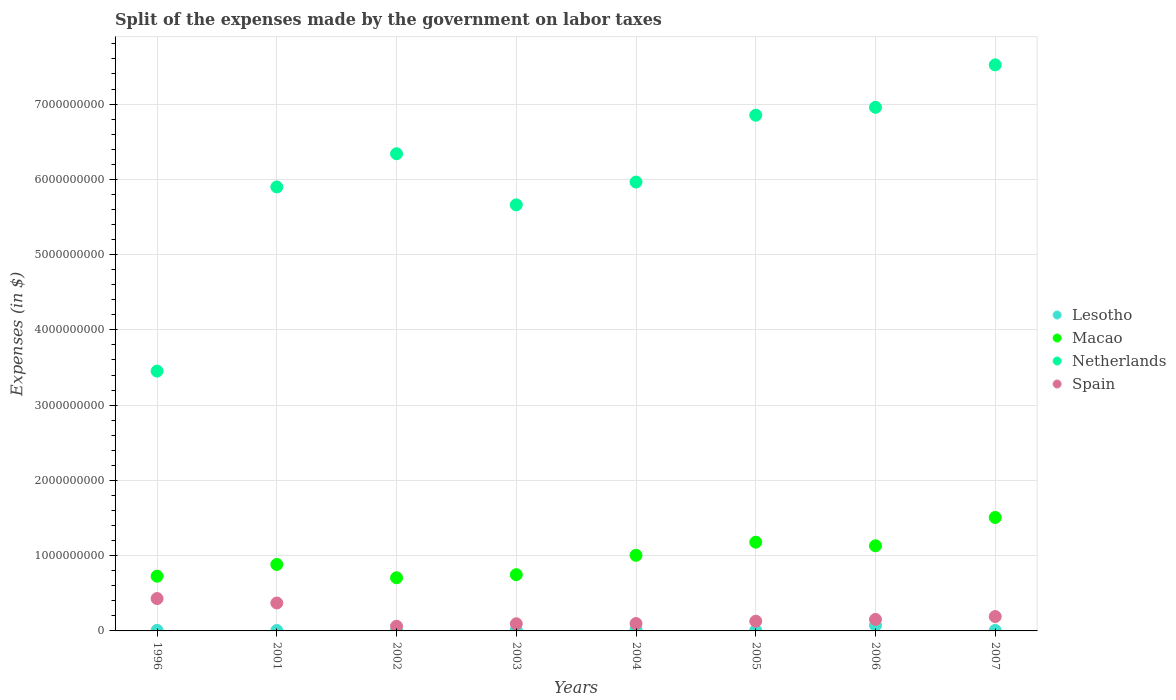Is the number of dotlines equal to the number of legend labels?
Offer a terse response. Yes. What is the expenses made by the government on labor taxes in Lesotho in 2003?
Give a very brief answer. 1.05e+07. Across all years, what is the maximum expenses made by the government on labor taxes in Lesotho?
Your answer should be compact. 7.48e+07. Across all years, what is the minimum expenses made by the government on labor taxes in Netherlands?
Your answer should be compact. 3.45e+09. In which year was the expenses made by the government on labor taxes in Macao maximum?
Give a very brief answer. 2007. In which year was the expenses made by the government on labor taxes in Spain minimum?
Offer a very short reply. 2002. What is the total expenses made by the government on labor taxes in Macao in the graph?
Offer a very short reply. 7.89e+09. What is the difference between the expenses made by the government on labor taxes in Netherlands in 2001 and that in 2003?
Provide a short and direct response. 2.38e+08. What is the difference between the expenses made by the government on labor taxes in Macao in 2002 and the expenses made by the government on labor taxes in Spain in 2005?
Provide a succinct answer. 5.77e+08. What is the average expenses made by the government on labor taxes in Macao per year?
Your answer should be compact. 9.86e+08. In the year 2005, what is the difference between the expenses made by the government on labor taxes in Macao and expenses made by the government on labor taxes in Lesotho?
Your answer should be very brief. 1.17e+09. What is the ratio of the expenses made by the government on labor taxes in Macao in 2004 to that in 2006?
Your answer should be very brief. 0.89. Is the expenses made by the government on labor taxes in Lesotho in 2001 less than that in 2007?
Provide a succinct answer. Yes. Is the difference between the expenses made by the government on labor taxes in Macao in 2001 and 2002 greater than the difference between the expenses made by the government on labor taxes in Lesotho in 2001 and 2002?
Your response must be concise. Yes. What is the difference between the highest and the second highest expenses made by the government on labor taxes in Macao?
Provide a short and direct response. 3.28e+08. What is the difference between the highest and the lowest expenses made by the government on labor taxes in Lesotho?
Offer a very short reply. 6.95e+07. In how many years, is the expenses made by the government on labor taxes in Netherlands greater than the average expenses made by the government on labor taxes in Netherlands taken over all years?
Provide a short and direct response. 4. Is it the case that in every year, the sum of the expenses made by the government on labor taxes in Macao and expenses made by the government on labor taxes in Netherlands  is greater than the sum of expenses made by the government on labor taxes in Lesotho and expenses made by the government on labor taxes in Spain?
Your answer should be very brief. Yes. Is the expenses made by the government on labor taxes in Macao strictly greater than the expenses made by the government on labor taxes in Spain over the years?
Your answer should be very brief. Yes. Is the expenses made by the government on labor taxes in Macao strictly less than the expenses made by the government on labor taxes in Spain over the years?
Make the answer very short. No. How many dotlines are there?
Ensure brevity in your answer.  4. Are the values on the major ticks of Y-axis written in scientific E-notation?
Provide a short and direct response. No. Does the graph contain any zero values?
Provide a succinct answer. No. How many legend labels are there?
Provide a short and direct response. 4. How are the legend labels stacked?
Your response must be concise. Vertical. What is the title of the graph?
Offer a very short reply. Split of the expenses made by the government on labor taxes. Does "Finland" appear as one of the legend labels in the graph?
Ensure brevity in your answer.  No. What is the label or title of the X-axis?
Offer a terse response. Years. What is the label or title of the Y-axis?
Provide a short and direct response. Expenses (in $). What is the Expenses (in $) in Lesotho in 1996?
Provide a succinct answer. 7.20e+06. What is the Expenses (in $) in Macao in 1996?
Provide a succinct answer. 7.27e+08. What is the Expenses (in $) in Netherlands in 1996?
Keep it short and to the point. 3.45e+09. What is the Expenses (in $) in Spain in 1996?
Give a very brief answer. 4.30e+08. What is the Expenses (in $) in Lesotho in 2001?
Offer a very short reply. 5.30e+06. What is the Expenses (in $) in Macao in 2001?
Your answer should be compact. 8.83e+08. What is the Expenses (in $) in Netherlands in 2001?
Offer a terse response. 5.90e+09. What is the Expenses (in $) of Spain in 2001?
Make the answer very short. 3.71e+08. What is the Expenses (in $) in Lesotho in 2002?
Provide a short and direct response. 6.40e+06. What is the Expenses (in $) in Macao in 2002?
Provide a short and direct response. 7.06e+08. What is the Expenses (in $) of Netherlands in 2002?
Provide a short and direct response. 6.34e+09. What is the Expenses (in $) in Spain in 2002?
Keep it short and to the point. 6.20e+07. What is the Expenses (in $) in Lesotho in 2003?
Provide a short and direct response. 1.05e+07. What is the Expenses (in $) of Macao in 2003?
Offer a very short reply. 7.47e+08. What is the Expenses (in $) in Netherlands in 2003?
Your response must be concise. 5.66e+09. What is the Expenses (in $) of Spain in 2003?
Give a very brief answer. 9.50e+07. What is the Expenses (in $) in Lesotho in 2004?
Make the answer very short. 1.78e+07. What is the Expenses (in $) of Macao in 2004?
Provide a succinct answer. 1.00e+09. What is the Expenses (in $) of Netherlands in 2004?
Offer a very short reply. 5.96e+09. What is the Expenses (in $) in Spain in 2004?
Keep it short and to the point. 9.80e+07. What is the Expenses (in $) in Lesotho in 2005?
Your answer should be very brief. 6.74e+06. What is the Expenses (in $) of Macao in 2005?
Your answer should be very brief. 1.18e+09. What is the Expenses (in $) of Netherlands in 2005?
Give a very brief answer. 6.85e+09. What is the Expenses (in $) in Spain in 2005?
Provide a succinct answer. 1.29e+08. What is the Expenses (in $) of Lesotho in 2006?
Your answer should be compact. 7.48e+07. What is the Expenses (in $) of Macao in 2006?
Provide a short and direct response. 1.13e+09. What is the Expenses (in $) in Netherlands in 2006?
Provide a succinct answer. 6.96e+09. What is the Expenses (in $) in Spain in 2006?
Keep it short and to the point. 1.53e+08. What is the Expenses (in $) of Lesotho in 2007?
Make the answer very short. 6.62e+06. What is the Expenses (in $) of Macao in 2007?
Make the answer very short. 1.51e+09. What is the Expenses (in $) of Netherlands in 2007?
Keep it short and to the point. 7.52e+09. What is the Expenses (in $) in Spain in 2007?
Keep it short and to the point. 1.91e+08. Across all years, what is the maximum Expenses (in $) in Lesotho?
Offer a terse response. 7.48e+07. Across all years, what is the maximum Expenses (in $) in Macao?
Provide a short and direct response. 1.51e+09. Across all years, what is the maximum Expenses (in $) of Netherlands?
Give a very brief answer. 7.52e+09. Across all years, what is the maximum Expenses (in $) of Spain?
Ensure brevity in your answer.  4.30e+08. Across all years, what is the minimum Expenses (in $) of Lesotho?
Offer a very short reply. 5.30e+06. Across all years, what is the minimum Expenses (in $) of Macao?
Offer a very short reply. 7.06e+08. Across all years, what is the minimum Expenses (in $) in Netherlands?
Offer a terse response. 3.45e+09. Across all years, what is the minimum Expenses (in $) in Spain?
Give a very brief answer. 6.20e+07. What is the total Expenses (in $) in Lesotho in the graph?
Give a very brief answer. 1.35e+08. What is the total Expenses (in $) of Macao in the graph?
Make the answer very short. 7.89e+09. What is the total Expenses (in $) of Netherlands in the graph?
Make the answer very short. 4.86e+1. What is the total Expenses (in $) in Spain in the graph?
Ensure brevity in your answer.  1.53e+09. What is the difference between the Expenses (in $) in Lesotho in 1996 and that in 2001?
Make the answer very short. 1.90e+06. What is the difference between the Expenses (in $) in Macao in 1996 and that in 2001?
Ensure brevity in your answer.  -1.56e+08. What is the difference between the Expenses (in $) in Netherlands in 1996 and that in 2001?
Provide a short and direct response. -2.45e+09. What is the difference between the Expenses (in $) in Spain in 1996 and that in 2001?
Your answer should be very brief. 5.90e+07. What is the difference between the Expenses (in $) of Macao in 1996 and that in 2002?
Provide a short and direct response. 2.08e+07. What is the difference between the Expenses (in $) of Netherlands in 1996 and that in 2002?
Your answer should be very brief. -2.89e+09. What is the difference between the Expenses (in $) of Spain in 1996 and that in 2002?
Your answer should be compact. 3.68e+08. What is the difference between the Expenses (in $) of Lesotho in 1996 and that in 2003?
Give a very brief answer. -3.28e+06. What is the difference between the Expenses (in $) in Macao in 1996 and that in 2003?
Make the answer very short. -1.99e+07. What is the difference between the Expenses (in $) of Netherlands in 1996 and that in 2003?
Provide a short and direct response. -2.21e+09. What is the difference between the Expenses (in $) of Spain in 1996 and that in 2003?
Give a very brief answer. 3.35e+08. What is the difference between the Expenses (in $) in Lesotho in 1996 and that in 2004?
Provide a short and direct response. -1.06e+07. What is the difference between the Expenses (in $) in Macao in 1996 and that in 2004?
Your answer should be very brief. -2.77e+08. What is the difference between the Expenses (in $) in Netherlands in 1996 and that in 2004?
Offer a very short reply. -2.51e+09. What is the difference between the Expenses (in $) of Spain in 1996 and that in 2004?
Your answer should be very brief. 3.32e+08. What is the difference between the Expenses (in $) in Lesotho in 1996 and that in 2005?
Provide a succinct answer. 4.65e+05. What is the difference between the Expenses (in $) of Macao in 1996 and that in 2005?
Provide a short and direct response. -4.52e+08. What is the difference between the Expenses (in $) in Netherlands in 1996 and that in 2005?
Make the answer very short. -3.40e+09. What is the difference between the Expenses (in $) in Spain in 1996 and that in 2005?
Your answer should be compact. 3.01e+08. What is the difference between the Expenses (in $) of Lesotho in 1996 and that in 2006?
Your answer should be very brief. -6.76e+07. What is the difference between the Expenses (in $) of Macao in 1996 and that in 2006?
Keep it short and to the point. -4.04e+08. What is the difference between the Expenses (in $) of Netherlands in 1996 and that in 2006?
Make the answer very short. -3.50e+09. What is the difference between the Expenses (in $) in Spain in 1996 and that in 2006?
Give a very brief answer. 2.77e+08. What is the difference between the Expenses (in $) in Lesotho in 1996 and that in 2007?
Make the answer very short. 5.81e+05. What is the difference between the Expenses (in $) in Macao in 1996 and that in 2007?
Provide a short and direct response. -7.80e+08. What is the difference between the Expenses (in $) in Netherlands in 1996 and that in 2007?
Provide a succinct answer. -4.07e+09. What is the difference between the Expenses (in $) of Spain in 1996 and that in 2007?
Your answer should be very brief. 2.39e+08. What is the difference between the Expenses (in $) in Lesotho in 2001 and that in 2002?
Ensure brevity in your answer.  -1.10e+06. What is the difference between the Expenses (in $) of Macao in 2001 and that in 2002?
Your answer should be very brief. 1.77e+08. What is the difference between the Expenses (in $) of Netherlands in 2001 and that in 2002?
Your answer should be very brief. -4.41e+08. What is the difference between the Expenses (in $) of Spain in 2001 and that in 2002?
Offer a very short reply. 3.09e+08. What is the difference between the Expenses (in $) of Lesotho in 2001 and that in 2003?
Ensure brevity in your answer.  -5.18e+06. What is the difference between the Expenses (in $) in Macao in 2001 and that in 2003?
Ensure brevity in your answer.  1.36e+08. What is the difference between the Expenses (in $) of Netherlands in 2001 and that in 2003?
Keep it short and to the point. 2.38e+08. What is the difference between the Expenses (in $) in Spain in 2001 and that in 2003?
Keep it short and to the point. 2.76e+08. What is the difference between the Expenses (in $) in Lesotho in 2001 and that in 2004?
Your answer should be very brief. -1.25e+07. What is the difference between the Expenses (in $) of Macao in 2001 and that in 2004?
Provide a succinct answer. -1.22e+08. What is the difference between the Expenses (in $) in Netherlands in 2001 and that in 2004?
Provide a succinct answer. -6.50e+07. What is the difference between the Expenses (in $) in Spain in 2001 and that in 2004?
Provide a short and direct response. 2.73e+08. What is the difference between the Expenses (in $) of Lesotho in 2001 and that in 2005?
Make the answer very short. -1.44e+06. What is the difference between the Expenses (in $) in Macao in 2001 and that in 2005?
Your response must be concise. -2.96e+08. What is the difference between the Expenses (in $) of Netherlands in 2001 and that in 2005?
Your response must be concise. -9.53e+08. What is the difference between the Expenses (in $) in Spain in 2001 and that in 2005?
Provide a succinct answer. 2.42e+08. What is the difference between the Expenses (in $) in Lesotho in 2001 and that in 2006?
Make the answer very short. -6.95e+07. What is the difference between the Expenses (in $) of Macao in 2001 and that in 2006?
Offer a terse response. -2.48e+08. What is the difference between the Expenses (in $) of Netherlands in 2001 and that in 2006?
Keep it short and to the point. -1.06e+09. What is the difference between the Expenses (in $) in Spain in 2001 and that in 2006?
Keep it short and to the point. 2.18e+08. What is the difference between the Expenses (in $) of Lesotho in 2001 and that in 2007?
Provide a succinct answer. -1.32e+06. What is the difference between the Expenses (in $) of Macao in 2001 and that in 2007?
Your response must be concise. -6.24e+08. What is the difference between the Expenses (in $) of Netherlands in 2001 and that in 2007?
Your answer should be compact. -1.62e+09. What is the difference between the Expenses (in $) in Spain in 2001 and that in 2007?
Ensure brevity in your answer.  1.80e+08. What is the difference between the Expenses (in $) in Lesotho in 2002 and that in 2003?
Provide a short and direct response. -4.08e+06. What is the difference between the Expenses (in $) in Macao in 2002 and that in 2003?
Ensure brevity in your answer.  -4.07e+07. What is the difference between the Expenses (in $) of Netherlands in 2002 and that in 2003?
Provide a short and direct response. 6.79e+08. What is the difference between the Expenses (in $) of Spain in 2002 and that in 2003?
Your answer should be compact. -3.30e+07. What is the difference between the Expenses (in $) of Lesotho in 2002 and that in 2004?
Provide a short and direct response. -1.14e+07. What is the difference between the Expenses (in $) in Macao in 2002 and that in 2004?
Your response must be concise. -2.98e+08. What is the difference between the Expenses (in $) in Netherlands in 2002 and that in 2004?
Offer a very short reply. 3.76e+08. What is the difference between the Expenses (in $) of Spain in 2002 and that in 2004?
Provide a short and direct response. -3.60e+07. What is the difference between the Expenses (in $) in Lesotho in 2002 and that in 2005?
Offer a very short reply. -3.35e+05. What is the difference between the Expenses (in $) of Macao in 2002 and that in 2005?
Provide a succinct answer. -4.73e+08. What is the difference between the Expenses (in $) in Netherlands in 2002 and that in 2005?
Give a very brief answer. -5.12e+08. What is the difference between the Expenses (in $) in Spain in 2002 and that in 2005?
Your answer should be compact. -6.70e+07. What is the difference between the Expenses (in $) in Lesotho in 2002 and that in 2006?
Make the answer very short. -6.84e+07. What is the difference between the Expenses (in $) in Macao in 2002 and that in 2006?
Your answer should be compact. -4.25e+08. What is the difference between the Expenses (in $) in Netherlands in 2002 and that in 2006?
Provide a succinct answer. -6.17e+08. What is the difference between the Expenses (in $) in Spain in 2002 and that in 2006?
Provide a short and direct response. -9.10e+07. What is the difference between the Expenses (in $) of Lesotho in 2002 and that in 2007?
Provide a succinct answer. -2.19e+05. What is the difference between the Expenses (in $) in Macao in 2002 and that in 2007?
Your answer should be very brief. -8.01e+08. What is the difference between the Expenses (in $) in Netherlands in 2002 and that in 2007?
Your response must be concise. -1.18e+09. What is the difference between the Expenses (in $) of Spain in 2002 and that in 2007?
Your answer should be very brief. -1.29e+08. What is the difference between the Expenses (in $) of Lesotho in 2003 and that in 2004?
Your answer should be compact. -7.32e+06. What is the difference between the Expenses (in $) of Macao in 2003 and that in 2004?
Your answer should be compact. -2.57e+08. What is the difference between the Expenses (in $) of Netherlands in 2003 and that in 2004?
Your response must be concise. -3.03e+08. What is the difference between the Expenses (in $) of Spain in 2003 and that in 2004?
Offer a very short reply. -3.00e+06. What is the difference between the Expenses (in $) of Lesotho in 2003 and that in 2005?
Provide a succinct answer. 3.74e+06. What is the difference between the Expenses (in $) in Macao in 2003 and that in 2005?
Your answer should be very brief. -4.32e+08. What is the difference between the Expenses (in $) in Netherlands in 2003 and that in 2005?
Provide a short and direct response. -1.19e+09. What is the difference between the Expenses (in $) of Spain in 2003 and that in 2005?
Provide a succinct answer. -3.40e+07. What is the difference between the Expenses (in $) of Lesotho in 2003 and that in 2006?
Ensure brevity in your answer.  -6.43e+07. What is the difference between the Expenses (in $) in Macao in 2003 and that in 2006?
Your response must be concise. -3.84e+08. What is the difference between the Expenses (in $) in Netherlands in 2003 and that in 2006?
Provide a succinct answer. -1.30e+09. What is the difference between the Expenses (in $) in Spain in 2003 and that in 2006?
Make the answer very short. -5.80e+07. What is the difference between the Expenses (in $) of Lesotho in 2003 and that in 2007?
Your answer should be very brief. 3.86e+06. What is the difference between the Expenses (in $) of Macao in 2003 and that in 2007?
Your answer should be compact. -7.60e+08. What is the difference between the Expenses (in $) in Netherlands in 2003 and that in 2007?
Provide a succinct answer. -1.86e+09. What is the difference between the Expenses (in $) of Spain in 2003 and that in 2007?
Provide a short and direct response. -9.60e+07. What is the difference between the Expenses (in $) of Lesotho in 2004 and that in 2005?
Your answer should be very brief. 1.11e+07. What is the difference between the Expenses (in $) of Macao in 2004 and that in 2005?
Give a very brief answer. -1.74e+08. What is the difference between the Expenses (in $) of Netherlands in 2004 and that in 2005?
Your answer should be compact. -8.88e+08. What is the difference between the Expenses (in $) of Spain in 2004 and that in 2005?
Ensure brevity in your answer.  -3.10e+07. What is the difference between the Expenses (in $) of Lesotho in 2004 and that in 2006?
Offer a very short reply. -5.70e+07. What is the difference between the Expenses (in $) in Macao in 2004 and that in 2006?
Your answer should be compact. -1.26e+08. What is the difference between the Expenses (in $) in Netherlands in 2004 and that in 2006?
Your answer should be very brief. -9.93e+08. What is the difference between the Expenses (in $) in Spain in 2004 and that in 2006?
Your response must be concise. -5.50e+07. What is the difference between the Expenses (in $) of Lesotho in 2004 and that in 2007?
Offer a very short reply. 1.12e+07. What is the difference between the Expenses (in $) in Macao in 2004 and that in 2007?
Make the answer very short. -5.03e+08. What is the difference between the Expenses (in $) in Netherlands in 2004 and that in 2007?
Provide a short and direct response. -1.56e+09. What is the difference between the Expenses (in $) in Spain in 2004 and that in 2007?
Offer a terse response. -9.30e+07. What is the difference between the Expenses (in $) of Lesotho in 2005 and that in 2006?
Make the answer very short. -6.81e+07. What is the difference between the Expenses (in $) of Macao in 2005 and that in 2006?
Offer a very short reply. 4.80e+07. What is the difference between the Expenses (in $) in Netherlands in 2005 and that in 2006?
Provide a succinct answer. -1.05e+08. What is the difference between the Expenses (in $) of Spain in 2005 and that in 2006?
Keep it short and to the point. -2.40e+07. What is the difference between the Expenses (in $) in Lesotho in 2005 and that in 2007?
Keep it short and to the point. 1.16e+05. What is the difference between the Expenses (in $) of Macao in 2005 and that in 2007?
Make the answer very short. -3.28e+08. What is the difference between the Expenses (in $) of Netherlands in 2005 and that in 2007?
Offer a terse response. -6.69e+08. What is the difference between the Expenses (in $) in Spain in 2005 and that in 2007?
Your response must be concise. -6.20e+07. What is the difference between the Expenses (in $) in Lesotho in 2006 and that in 2007?
Ensure brevity in your answer.  6.82e+07. What is the difference between the Expenses (in $) of Macao in 2006 and that in 2007?
Provide a short and direct response. -3.76e+08. What is the difference between the Expenses (in $) of Netherlands in 2006 and that in 2007?
Your response must be concise. -5.64e+08. What is the difference between the Expenses (in $) in Spain in 2006 and that in 2007?
Ensure brevity in your answer.  -3.80e+07. What is the difference between the Expenses (in $) of Lesotho in 1996 and the Expenses (in $) of Macao in 2001?
Provide a succinct answer. -8.76e+08. What is the difference between the Expenses (in $) in Lesotho in 1996 and the Expenses (in $) in Netherlands in 2001?
Offer a very short reply. -5.89e+09. What is the difference between the Expenses (in $) in Lesotho in 1996 and the Expenses (in $) in Spain in 2001?
Your answer should be compact. -3.64e+08. What is the difference between the Expenses (in $) of Macao in 1996 and the Expenses (in $) of Netherlands in 2001?
Your response must be concise. -5.17e+09. What is the difference between the Expenses (in $) of Macao in 1996 and the Expenses (in $) of Spain in 2001?
Offer a terse response. 3.56e+08. What is the difference between the Expenses (in $) of Netherlands in 1996 and the Expenses (in $) of Spain in 2001?
Ensure brevity in your answer.  3.08e+09. What is the difference between the Expenses (in $) in Lesotho in 1996 and the Expenses (in $) in Macao in 2002?
Give a very brief answer. -6.99e+08. What is the difference between the Expenses (in $) of Lesotho in 1996 and the Expenses (in $) of Netherlands in 2002?
Your response must be concise. -6.33e+09. What is the difference between the Expenses (in $) of Lesotho in 1996 and the Expenses (in $) of Spain in 2002?
Your answer should be compact. -5.48e+07. What is the difference between the Expenses (in $) in Macao in 1996 and the Expenses (in $) in Netherlands in 2002?
Provide a short and direct response. -5.61e+09. What is the difference between the Expenses (in $) in Macao in 1996 and the Expenses (in $) in Spain in 2002?
Give a very brief answer. 6.65e+08. What is the difference between the Expenses (in $) of Netherlands in 1996 and the Expenses (in $) of Spain in 2002?
Make the answer very short. 3.39e+09. What is the difference between the Expenses (in $) in Lesotho in 1996 and the Expenses (in $) in Macao in 2003?
Provide a succinct answer. -7.40e+08. What is the difference between the Expenses (in $) of Lesotho in 1996 and the Expenses (in $) of Netherlands in 2003?
Make the answer very short. -5.65e+09. What is the difference between the Expenses (in $) of Lesotho in 1996 and the Expenses (in $) of Spain in 2003?
Give a very brief answer. -8.78e+07. What is the difference between the Expenses (in $) of Macao in 1996 and the Expenses (in $) of Netherlands in 2003?
Ensure brevity in your answer.  -4.93e+09. What is the difference between the Expenses (in $) in Macao in 1996 and the Expenses (in $) in Spain in 2003?
Your answer should be very brief. 6.32e+08. What is the difference between the Expenses (in $) in Netherlands in 1996 and the Expenses (in $) in Spain in 2003?
Provide a succinct answer. 3.36e+09. What is the difference between the Expenses (in $) in Lesotho in 1996 and the Expenses (in $) in Macao in 2004?
Offer a terse response. -9.97e+08. What is the difference between the Expenses (in $) in Lesotho in 1996 and the Expenses (in $) in Netherlands in 2004?
Provide a succinct answer. -5.96e+09. What is the difference between the Expenses (in $) of Lesotho in 1996 and the Expenses (in $) of Spain in 2004?
Offer a very short reply. -9.08e+07. What is the difference between the Expenses (in $) in Macao in 1996 and the Expenses (in $) in Netherlands in 2004?
Offer a very short reply. -5.24e+09. What is the difference between the Expenses (in $) of Macao in 1996 and the Expenses (in $) of Spain in 2004?
Your response must be concise. 6.29e+08. What is the difference between the Expenses (in $) in Netherlands in 1996 and the Expenses (in $) in Spain in 2004?
Provide a succinct answer. 3.35e+09. What is the difference between the Expenses (in $) in Lesotho in 1996 and the Expenses (in $) in Macao in 2005?
Give a very brief answer. -1.17e+09. What is the difference between the Expenses (in $) in Lesotho in 1996 and the Expenses (in $) in Netherlands in 2005?
Your answer should be compact. -6.84e+09. What is the difference between the Expenses (in $) in Lesotho in 1996 and the Expenses (in $) in Spain in 2005?
Your answer should be compact. -1.22e+08. What is the difference between the Expenses (in $) in Macao in 1996 and the Expenses (in $) in Netherlands in 2005?
Offer a very short reply. -6.12e+09. What is the difference between the Expenses (in $) in Macao in 1996 and the Expenses (in $) in Spain in 2005?
Provide a short and direct response. 5.98e+08. What is the difference between the Expenses (in $) of Netherlands in 1996 and the Expenses (in $) of Spain in 2005?
Your answer should be very brief. 3.32e+09. What is the difference between the Expenses (in $) in Lesotho in 1996 and the Expenses (in $) in Macao in 2006?
Make the answer very short. -1.12e+09. What is the difference between the Expenses (in $) of Lesotho in 1996 and the Expenses (in $) of Netherlands in 2006?
Keep it short and to the point. -6.95e+09. What is the difference between the Expenses (in $) in Lesotho in 1996 and the Expenses (in $) in Spain in 2006?
Offer a terse response. -1.46e+08. What is the difference between the Expenses (in $) of Macao in 1996 and the Expenses (in $) of Netherlands in 2006?
Offer a terse response. -6.23e+09. What is the difference between the Expenses (in $) in Macao in 1996 and the Expenses (in $) in Spain in 2006?
Provide a succinct answer. 5.74e+08. What is the difference between the Expenses (in $) in Netherlands in 1996 and the Expenses (in $) in Spain in 2006?
Your response must be concise. 3.30e+09. What is the difference between the Expenses (in $) in Lesotho in 1996 and the Expenses (in $) in Macao in 2007?
Ensure brevity in your answer.  -1.50e+09. What is the difference between the Expenses (in $) in Lesotho in 1996 and the Expenses (in $) in Netherlands in 2007?
Your answer should be compact. -7.51e+09. What is the difference between the Expenses (in $) in Lesotho in 1996 and the Expenses (in $) in Spain in 2007?
Offer a terse response. -1.84e+08. What is the difference between the Expenses (in $) in Macao in 1996 and the Expenses (in $) in Netherlands in 2007?
Give a very brief answer. -6.79e+09. What is the difference between the Expenses (in $) in Macao in 1996 and the Expenses (in $) in Spain in 2007?
Make the answer very short. 5.36e+08. What is the difference between the Expenses (in $) in Netherlands in 1996 and the Expenses (in $) in Spain in 2007?
Keep it short and to the point. 3.26e+09. What is the difference between the Expenses (in $) in Lesotho in 2001 and the Expenses (in $) in Macao in 2002?
Offer a very short reply. -7.01e+08. What is the difference between the Expenses (in $) in Lesotho in 2001 and the Expenses (in $) in Netherlands in 2002?
Offer a terse response. -6.33e+09. What is the difference between the Expenses (in $) of Lesotho in 2001 and the Expenses (in $) of Spain in 2002?
Your answer should be very brief. -5.67e+07. What is the difference between the Expenses (in $) in Macao in 2001 and the Expenses (in $) in Netherlands in 2002?
Your answer should be very brief. -5.46e+09. What is the difference between the Expenses (in $) in Macao in 2001 and the Expenses (in $) in Spain in 2002?
Keep it short and to the point. 8.21e+08. What is the difference between the Expenses (in $) of Netherlands in 2001 and the Expenses (in $) of Spain in 2002?
Provide a succinct answer. 5.84e+09. What is the difference between the Expenses (in $) of Lesotho in 2001 and the Expenses (in $) of Macao in 2003?
Your answer should be very brief. -7.42e+08. What is the difference between the Expenses (in $) of Lesotho in 2001 and the Expenses (in $) of Netherlands in 2003?
Offer a very short reply. -5.66e+09. What is the difference between the Expenses (in $) in Lesotho in 2001 and the Expenses (in $) in Spain in 2003?
Give a very brief answer. -8.97e+07. What is the difference between the Expenses (in $) of Macao in 2001 and the Expenses (in $) of Netherlands in 2003?
Make the answer very short. -4.78e+09. What is the difference between the Expenses (in $) in Macao in 2001 and the Expenses (in $) in Spain in 2003?
Provide a short and direct response. 7.88e+08. What is the difference between the Expenses (in $) of Netherlands in 2001 and the Expenses (in $) of Spain in 2003?
Keep it short and to the point. 5.80e+09. What is the difference between the Expenses (in $) of Lesotho in 2001 and the Expenses (in $) of Macao in 2004?
Make the answer very short. -9.99e+08. What is the difference between the Expenses (in $) in Lesotho in 2001 and the Expenses (in $) in Netherlands in 2004?
Offer a very short reply. -5.96e+09. What is the difference between the Expenses (in $) of Lesotho in 2001 and the Expenses (in $) of Spain in 2004?
Your response must be concise. -9.27e+07. What is the difference between the Expenses (in $) of Macao in 2001 and the Expenses (in $) of Netherlands in 2004?
Provide a succinct answer. -5.08e+09. What is the difference between the Expenses (in $) in Macao in 2001 and the Expenses (in $) in Spain in 2004?
Provide a short and direct response. 7.85e+08. What is the difference between the Expenses (in $) in Netherlands in 2001 and the Expenses (in $) in Spain in 2004?
Ensure brevity in your answer.  5.80e+09. What is the difference between the Expenses (in $) of Lesotho in 2001 and the Expenses (in $) of Macao in 2005?
Offer a very short reply. -1.17e+09. What is the difference between the Expenses (in $) in Lesotho in 2001 and the Expenses (in $) in Netherlands in 2005?
Offer a terse response. -6.85e+09. What is the difference between the Expenses (in $) of Lesotho in 2001 and the Expenses (in $) of Spain in 2005?
Offer a very short reply. -1.24e+08. What is the difference between the Expenses (in $) of Macao in 2001 and the Expenses (in $) of Netherlands in 2005?
Your response must be concise. -5.97e+09. What is the difference between the Expenses (in $) in Macao in 2001 and the Expenses (in $) in Spain in 2005?
Ensure brevity in your answer.  7.54e+08. What is the difference between the Expenses (in $) of Netherlands in 2001 and the Expenses (in $) of Spain in 2005?
Offer a terse response. 5.77e+09. What is the difference between the Expenses (in $) in Lesotho in 2001 and the Expenses (in $) in Macao in 2006?
Give a very brief answer. -1.13e+09. What is the difference between the Expenses (in $) of Lesotho in 2001 and the Expenses (in $) of Netherlands in 2006?
Ensure brevity in your answer.  -6.95e+09. What is the difference between the Expenses (in $) of Lesotho in 2001 and the Expenses (in $) of Spain in 2006?
Your response must be concise. -1.48e+08. What is the difference between the Expenses (in $) of Macao in 2001 and the Expenses (in $) of Netherlands in 2006?
Ensure brevity in your answer.  -6.07e+09. What is the difference between the Expenses (in $) of Macao in 2001 and the Expenses (in $) of Spain in 2006?
Provide a succinct answer. 7.30e+08. What is the difference between the Expenses (in $) of Netherlands in 2001 and the Expenses (in $) of Spain in 2006?
Ensure brevity in your answer.  5.75e+09. What is the difference between the Expenses (in $) in Lesotho in 2001 and the Expenses (in $) in Macao in 2007?
Ensure brevity in your answer.  -1.50e+09. What is the difference between the Expenses (in $) of Lesotho in 2001 and the Expenses (in $) of Netherlands in 2007?
Your answer should be compact. -7.52e+09. What is the difference between the Expenses (in $) of Lesotho in 2001 and the Expenses (in $) of Spain in 2007?
Your answer should be very brief. -1.86e+08. What is the difference between the Expenses (in $) in Macao in 2001 and the Expenses (in $) in Netherlands in 2007?
Make the answer very short. -6.64e+09. What is the difference between the Expenses (in $) in Macao in 2001 and the Expenses (in $) in Spain in 2007?
Make the answer very short. 6.92e+08. What is the difference between the Expenses (in $) of Netherlands in 2001 and the Expenses (in $) of Spain in 2007?
Offer a terse response. 5.71e+09. What is the difference between the Expenses (in $) of Lesotho in 2002 and the Expenses (in $) of Macao in 2003?
Your answer should be compact. -7.41e+08. What is the difference between the Expenses (in $) in Lesotho in 2002 and the Expenses (in $) in Netherlands in 2003?
Keep it short and to the point. -5.65e+09. What is the difference between the Expenses (in $) in Lesotho in 2002 and the Expenses (in $) in Spain in 2003?
Your response must be concise. -8.86e+07. What is the difference between the Expenses (in $) in Macao in 2002 and the Expenses (in $) in Netherlands in 2003?
Your response must be concise. -4.95e+09. What is the difference between the Expenses (in $) in Macao in 2002 and the Expenses (in $) in Spain in 2003?
Ensure brevity in your answer.  6.11e+08. What is the difference between the Expenses (in $) of Netherlands in 2002 and the Expenses (in $) of Spain in 2003?
Your response must be concise. 6.24e+09. What is the difference between the Expenses (in $) of Lesotho in 2002 and the Expenses (in $) of Macao in 2004?
Your answer should be compact. -9.98e+08. What is the difference between the Expenses (in $) of Lesotho in 2002 and the Expenses (in $) of Netherlands in 2004?
Your response must be concise. -5.96e+09. What is the difference between the Expenses (in $) in Lesotho in 2002 and the Expenses (in $) in Spain in 2004?
Give a very brief answer. -9.16e+07. What is the difference between the Expenses (in $) in Macao in 2002 and the Expenses (in $) in Netherlands in 2004?
Your response must be concise. -5.26e+09. What is the difference between the Expenses (in $) of Macao in 2002 and the Expenses (in $) of Spain in 2004?
Your answer should be compact. 6.08e+08. What is the difference between the Expenses (in $) of Netherlands in 2002 and the Expenses (in $) of Spain in 2004?
Offer a terse response. 6.24e+09. What is the difference between the Expenses (in $) in Lesotho in 2002 and the Expenses (in $) in Macao in 2005?
Provide a succinct answer. -1.17e+09. What is the difference between the Expenses (in $) of Lesotho in 2002 and the Expenses (in $) of Netherlands in 2005?
Keep it short and to the point. -6.85e+09. What is the difference between the Expenses (in $) in Lesotho in 2002 and the Expenses (in $) in Spain in 2005?
Ensure brevity in your answer.  -1.23e+08. What is the difference between the Expenses (in $) in Macao in 2002 and the Expenses (in $) in Netherlands in 2005?
Give a very brief answer. -6.15e+09. What is the difference between the Expenses (in $) in Macao in 2002 and the Expenses (in $) in Spain in 2005?
Your response must be concise. 5.77e+08. What is the difference between the Expenses (in $) of Netherlands in 2002 and the Expenses (in $) of Spain in 2005?
Give a very brief answer. 6.21e+09. What is the difference between the Expenses (in $) of Lesotho in 2002 and the Expenses (in $) of Macao in 2006?
Offer a terse response. -1.12e+09. What is the difference between the Expenses (in $) in Lesotho in 2002 and the Expenses (in $) in Netherlands in 2006?
Provide a short and direct response. -6.95e+09. What is the difference between the Expenses (in $) of Lesotho in 2002 and the Expenses (in $) of Spain in 2006?
Make the answer very short. -1.47e+08. What is the difference between the Expenses (in $) of Macao in 2002 and the Expenses (in $) of Netherlands in 2006?
Your answer should be very brief. -6.25e+09. What is the difference between the Expenses (in $) of Macao in 2002 and the Expenses (in $) of Spain in 2006?
Offer a terse response. 5.53e+08. What is the difference between the Expenses (in $) of Netherlands in 2002 and the Expenses (in $) of Spain in 2006?
Provide a succinct answer. 6.19e+09. What is the difference between the Expenses (in $) of Lesotho in 2002 and the Expenses (in $) of Macao in 2007?
Give a very brief answer. -1.50e+09. What is the difference between the Expenses (in $) in Lesotho in 2002 and the Expenses (in $) in Netherlands in 2007?
Provide a short and direct response. -7.51e+09. What is the difference between the Expenses (in $) of Lesotho in 2002 and the Expenses (in $) of Spain in 2007?
Provide a short and direct response. -1.85e+08. What is the difference between the Expenses (in $) in Macao in 2002 and the Expenses (in $) in Netherlands in 2007?
Provide a short and direct response. -6.81e+09. What is the difference between the Expenses (in $) of Macao in 2002 and the Expenses (in $) of Spain in 2007?
Your response must be concise. 5.15e+08. What is the difference between the Expenses (in $) of Netherlands in 2002 and the Expenses (in $) of Spain in 2007?
Your answer should be compact. 6.15e+09. What is the difference between the Expenses (in $) of Lesotho in 2003 and the Expenses (in $) of Macao in 2004?
Ensure brevity in your answer.  -9.94e+08. What is the difference between the Expenses (in $) of Lesotho in 2003 and the Expenses (in $) of Netherlands in 2004?
Your answer should be compact. -5.95e+09. What is the difference between the Expenses (in $) of Lesotho in 2003 and the Expenses (in $) of Spain in 2004?
Make the answer very short. -8.75e+07. What is the difference between the Expenses (in $) in Macao in 2003 and the Expenses (in $) in Netherlands in 2004?
Provide a short and direct response. -5.22e+09. What is the difference between the Expenses (in $) in Macao in 2003 and the Expenses (in $) in Spain in 2004?
Keep it short and to the point. 6.49e+08. What is the difference between the Expenses (in $) of Netherlands in 2003 and the Expenses (in $) of Spain in 2004?
Ensure brevity in your answer.  5.56e+09. What is the difference between the Expenses (in $) of Lesotho in 2003 and the Expenses (in $) of Macao in 2005?
Keep it short and to the point. -1.17e+09. What is the difference between the Expenses (in $) of Lesotho in 2003 and the Expenses (in $) of Netherlands in 2005?
Provide a succinct answer. -6.84e+09. What is the difference between the Expenses (in $) of Lesotho in 2003 and the Expenses (in $) of Spain in 2005?
Offer a very short reply. -1.19e+08. What is the difference between the Expenses (in $) in Macao in 2003 and the Expenses (in $) in Netherlands in 2005?
Give a very brief answer. -6.10e+09. What is the difference between the Expenses (in $) in Macao in 2003 and the Expenses (in $) in Spain in 2005?
Ensure brevity in your answer.  6.18e+08. What is the difference between the Expenses (in $) of Netherlands in 2003 and the Expenses (in $) of Spain in 2005?
Offer a terse response. 5.53e+09. What is the difference between the Expenses (in $) in Lesotho in 2003 and the Expenses (in $) in Macao in 2006?
Your response must be concise. -1.12e+09. What is the difference between the Expenses (in $) of Lesotho in 2003 and the Expenses (in $) of Netherlands in 2006?
Your answer should be very brief. -6.95e+09. What is the difference between the Expenses (in $) of Lesotho in 2003 and the Expenses (in $) of Spain in 2006?
Your response must be concise. -1.43e+08. What is the difference between the Expenses (in $) of Macao in 2003 and the Expenses (in $) of Netherlands in 2006?
Your response must be concise. -6.21e+09. What is the difference between the Expenses (in $) in Macao in 2003 and the Expenses (in $) in Spain in 2006?
Give a very brief answer. 5.94e+08. What is the difference between the Expenses (in $) in Netherlands in 2003 and the Expenses (in $) in Spain in 2006?
Make the answer very short. 5.51e+09. What is the difference between the Expenses (in $) in Lesotho in 2003 and the Expenses (in $) in Macao in 2007?
Give a very brief answer. -1.50e+09. What is the difference between the Expenses (in $) of Lesotho in 2003 and the Expenses (in $) of Netherlands in 2007?
Ensure brevity in your answer.  -7.51e+09. What is the difference between the Expenses (in $) of Lesotho in 2003 and the Expenses (in $) of Spain in 2007?
Provide a succinct answer. -1.81e+08. What is the difference between the Expenses (in $) of Macao in 2003 and the Expenses (in $) of Netherlands in 2007?
Provide a short and direct response. -6.77e+09. What is the difference between the Expenses (in $) in Macao in 2003 and the Expenses (in $) in Spain in 2007?
Offer a terse response. 5.56e+08. What is the difference between the Expenses (in $) of Netherlands in 2003 and the Expenses (in $) of Spain in 2007?
Offer a terse response. 5.47e+09. What is the difference between the Expenses (in $) in Lesotho in 2004 and the Expenses (in $) in Macao in 2005?
Offer a very short reply. -1.16e+09. What is the difference between the Expenses (in $) of Lesotho in 2004 and the Expenses (in $) of Netherlands in 2005?
Ensure brevity in your answer.  -6.83e+09. What is the difference between the Expenses (in $) of Lesotho in 2004 and the Expenses (in $) of Spain in 2005?
Make the answer very short. -1.11e+08. What is the difference between the Expenses (in $) in Macao in 2004 and the Expenses (in $) in Netherlands in 2005?
Make the answer very short. -5.85e+09. What is the difference between the Expenses (in $) of Macao in 2004 and the Expenses (in $) of Spain in 2005?
Give a very brief answer. 8.76e+08. What is the difference between the Expenses (in $) of Netherlands in 2004 and the Expenses (in $) of Spain in 2005?
Ensure brevity in your answer.  5.84e+09. What is the difference between the Expenses (in $) in Lesotho in 2004 and the Expenses (in $) in Macao in 2006?
Provide a short and direct response. -1.11e+09. What is the difference between the Expenses (in $) of Lesotho in 2004 and the Expenses (in $) of Netherlands in 2006?
Provide a short and direct response. -6.94e+09. What is the difference between the Expenses (in $) of Lesotho in 2004 and the Expenses (in $) of Spain in 2006?
Your answer should be very brief. -1.35e+08. What is the difference between the Expenses (in $) of Macao in 2004 and the Expenses (in $) of Netherlands in 2006?
Your response must be concise. -5.95e+09. What is the difference between the Expenses (in $) in Macao in 2004 and the Expenses (in $) in Spain in 2006?
Your answer should be very brief. 8.52e+08. What is the difference between the Expenses (in $) of Netherlands in 2004 and the Expenses (in $) of Spain in 2006?
Offer a very short reply. 5.81e+09. What is the difference between the Expenses (in $) of Lesotho in 2004 and the Expenses (in $) of Macao in 2007?
Make the answer very short. -1.49e+09. What is the difference between the Expenses (in $) in Lesotho in 2004 and the Expenses (in $) in Netherlands in 2007?
Offer a terse response. -7.50e+09. What is the difference between the Expenses (in $) of Lesotho in 2004 and the Expenses (in $) of Spain in 2007?
Keep it short and to the point. -1.73e+08. What is the difference between the Expenses (in $) of Macao in 2004 and the Expenses (in $) of Netherlands in 2007?
Give a very brief answer. -6.52e+09. What is the difference between the Expenses (in $) in Macao in 2004 and the Expenses (in $) in Spain in 2007?
Your answer should be very brief. 8.14e+08. What is the difference between the Expenses (in $) in Netherlands in 2004 and the Expenses (in $) in Spain in 2007?
Offer a very short reply. 5.77e+09. What is the difference between the Expenses (in $) in Lesotho in 2005 and the Expenses (in $) in Macao in 2006?
Give a very brief answer. -1.12e+09. What is the difference between the Expenses (in $) in Lesotho in 2005 and the Expenses (in $) in Netherlands in 2006?
Offer a terse response. -6.95e+09. What is the difference between the Expenses (in $) in Lesotho in 2005 and the Expenses (in $) in Spain in 2006?
Offer a very short reply. -1.46e+08. What is the difference between the Expenses (in $) in Macao in 2005 and the Expenses (in $) in Netherlands in 2006?
Offer a very short reply. -5.78e+09. What is the difference between the Expenses (in $) in Macao in 2005 and the Expenses (in $) in Spain in 2006?
Provide a short and direct response. 1.03e+09. What is the difference between the Expenses (in $) in Netherlands in 2005 and the Expenses (in $) in Spain in 2006?
Your response must be concise. 6.70e+09. What is the difference between the Expenses (in $) in Lesotho in 2005 and the Expenses (in $) in Macao in 2007?
Offer a very short reply. -1.50e+09. What is the difference between the Expenses (in $) in Lesotho in 2005 and the Expenses (in $) in Netherlands in 2007?
Provide a succinct answer. -7.51e+09. What is the difference between the Expenses (in $) in Lesotho in 2005 and the Expenses (in $) in Spain in 2007?
Your answer should be compact. -1.84e+08. What is the difference between the Expenses (in $) in Macao in 2005 and the Expenses (in $) in Netherlands in 2007?
Offer a terse response. -6.34e+09. What is the difference between the Expenses (in $) in Macao in 2005 and the Expenses (in $) in Spain in 2007?
Provide a short and direct response. 9.88e+08. What is the difference between the Expenses (in $) of Netherlands in 2005 and the Expenses (in $) of Spain in 2007?
Give a very brief answer. 6.66e+09. What is the difference between the Expenses (in $) of Lesotho in 2006 and the Expenses (in $) of Macao in 2007?
Your answer should be compact. -1.43e+09. What is the difference between the Expenses (in $) in Lesotho in 2006 and the Expenses (in $) in Netherlands in 2007?
Keep it short and to the point. -7.45e+09. What is the difference between the Expenses (in $) in Lesotho in 2006 and the Expenses (in $) in Spain in 2007?
Provide a short and direct response. -1.16e+08. What is the difference between the Expenses (in $) in Macao in 2006 and the Expenses (in $) in Netherlands in 2007?
Offer a terse response. -6.39e+09. What is the difference between the Expenses (in $) in Macao in 2006 and the Expenses (in $) in Spain in 2007?
Give a very brief answer. 9.40e+08. What is the difference between the Expenses (in $) in Netherlands in 2006 and the Expenses (in $) in Spain in 2007?
Keep it short and to the point. 6.77e+09. What is the average Expenses (in $) in Lesotho per year?
Offer a very short reply. 1.69e+07. What is the average Expenses (in $) of Macao per year?
Provide a short and direct response. 9.86e+08. What is the average Expenses (in $) of Netherlands per year?
Your answer should be very brief. 6.08e+09. What is the average Expenses (in $) of Spain per year?
Offer a very short reply. 1.91e+08. In the year 1996, what is the difference between the Expenses (in $) of Lesotho and Expenses (in $) of Macao?
Provide a short and direct response. -7.20e+08. In the year 1996, what is the difference between the Expenses (in $) in Lesotho and Expenses (in $) in Netherlands?
Keep it short and to the point. -3.44e+09. In the year 1996, what is the difference between the Expenses (in $) in Lesotho and Expenses (in $) in Spain?
Provide a short and direct response. -4.23e+08. In the year 1996, what is the difference between the Expenses (in $) of Macao and Expenses (in $) of Netherlands?
Your answer should be compact. -2.72e+09. In the year 1996, what is the difference between the Expenses (in $) of Macao and Expenses (in $) of Spain?
Make the answer very short. 2.97e+08. In the year 1996, what is the difference between the Expenses (in $) of Netherlands and Expenses (in $) of Spain?
Ensure brevity in your answer.  3.02e+09. In the year 2001, what is the difference between the Expenses (in $) in Lesotho and Expenses (in $) in Macao?
Make the answer very short. -8.78e+08. In the year 2001, what is the difference between the Expenses (in $) in Lesotho and Expenses (in $) in Netherlands?
Make the answer very short. -5.89e+09. In the year 2001, what is the difference between the Expenses (in $) of Lesotho and Expenses (in $) of Spain?
Ensure brevity in your answer.  -3.66e+08. In the year 2001, what is the difference between the Expenses (in $) of Macao and Expenses (in $) of Netherlands?
Make the answer very short. -5.02e+09. In the year 2001, what is the difference between the Expenses (in $) in Macao and Expenses (in $) in Spain?
Provide a succinct answer. 5.12e+08. In the year 2001, what is the difference between the Expenses (in $) of Netherlands and Expenses (in $) of Spain?
Offer a terse response. 5.53e+09. In the year 2002, what is the difference between the Expenses (in $) in Lesotho and Expenses (in $) in Macao?
Your answer should be compact. -7.00e+08. In the year 2002, what is the difference between the Expenses (in $) in Lesotho and Expenses (in $) in Netherlands?
Offer a terse response. -6.33e+09. In the year 2002, what is the difference between the Expenses (in $) of Lesotho and Expenses (in $) of Spain?
Provide a short and direct response. -5.56e+07. In the year 2002, what is the difference between the Expenses (in $) of Macao and Expenses (in $) of Netherlands?
Ensure brevity in your answer.  -5.63e+09. In the year 2002, what is the difference between the Expenses (in $) in Macao and Expenses (in $) in Spain?
Provide a succinct answer. 6.44e+08. In the year 2002, what is the difference between the Expenses (in $) in Netherlands and Expenses (in $) in Spain?
Your response must be concise. 6.28e+09. In the year 2003, what is the difference between the Expenses (in $) of Lesotho and Expenses (in $) of Macao?
Make the answer very short. -7.37e+08. In the year 2003, what is the difference between the Expenses (in $) in Lesotho and Expenses (in $) in Netherlands?
Provide a succinct answer. -5.65e+09. In the year 2003, what is the difference between the Expenses (in $) in Lesotho and Expenses (in $) in Spain?
Provide a short and direct response. -8.45e+07. In the year 2003, what is the difference between the Expenses (in $) in Macao and Expenses (in $) in Netherlands?
Give a very brief answer. -4.91e+09. In the year 2003, what is the difference between the Expenses (in $) in Macao and Expenses (in $) in Spain?
Offer a very short reply. 6.52e+08. In the year 2003, what is the difference between the Expenses (in $) in Netherlands and Expenses (in $) in Spain?
Keep it short and to the point. 5.57e+09. In the year 2004, what is the difference between the Expenses (in $) of Lesotho and Expenses (in $) of Macao?
Give a very brief answer. -9.87e+08. In the year 2004, what is the difference between the Expenses (in $) of Lesotho and Expenses (in $) of Netherlands?
Offer a terse response. -5.95e+09. In the year 2004, what is the difference between the Expenses (in $) of Lesotho and Expenses (in $) of Spain?
Offer a very short reply. -8.02e+07. In the year 2004, what is the difference between the Expenses (in $) in Macao and Expenses (in $) in Netherlands?
Your answer should be compact. -4.96e+09. In the year 2004, what is the difference between the Expenses (in $) in Macao and Expenses (in $) in Spain?
Offer a terse response. 9.07e+08. In the year 2004, what is the difference between the Expenses (in $) of Netherlands and Expenses (in $) of Spain?
Offer a very short reply. 5.87e+09. In the year 2005, what is the difference between the Expenses (in $) in Lesotho and Expenses (in $) in Macao?
Ensure brevity in your answer.  -1.17e+09. In the year 2005, what is the difference between the Expenses (in $) in Lesotho and Expenses (in $) in Netherlands?
Provide a short and direct response. -6.85e+09. In the year 2005, what is the difference between the Expenses (in $) in Lesotho and Expenses (in $) in Spain?
Your answer should be compact. -1.22e+08. In the year 2005, what is the difference between the Expenses (in $) of Macao and Expenses (in $) of Netherlands?
Your answer should be very brief. -5.67e+09. In the year 2005, what is the difference between the Expenses (in $) in Macao and Expenses (in $) in Spain?
Offer a terse response. 1.05e+09. In the year 2005, what is the difference between the Expenses (in $) of Netherlands and Expenses (in $) of Spain?
Offer a terse response. 6.72e+09. In the year 2006, what is the difference between the Expenses (in $) in Lesotho and Expenses (in $) in Macao?
Provide a short and direct response. -1.06e+09. In the year 2006, what is the difference between the Expenses (in $) in Lesotho and Expenses (in $) in Netherlands?
Your response must be concise. -6.88e+09. In the year 2006, what is the difference between the Expenses (in $) in Lesotho and Expenses (in $) in Spain?
Provide a succinct answer. -7.82e+07. In the year 2006, what is the difference between the Expenses (in $) of Macao and Expenses (in $) of Netherlands?
Your response must be concise. -5.83e+09. In the year 2006, what is the difference between the Expenses (in $) of Macao and Expenses (in $) of Spain?
Ensure brevity in your answer.  9.78e+08. In the year 2006, what is the difference between the Expenses (in $) in Netherlands and Expenses (in $) in Spain?
Offer a terse response. 6.80e+09. In the year 2007, what is the difference between the Expenses (in $) in Lesotho and Expenses (in $) in Macao?
Make the answer very short. -1.50e+09. In the year 2007, what is the difference between the Expenses (in $) in Lesotho and Expenses (in $) in Netherlands?
Offer a terse response. -7.51e+09. In the year 2007, what is the difference between the Expenses (in $) in Lesotho and Expenses (in $) in Spain?
Give a very brief answer. -1.84e+08. In the year 2007, what is the difference between the Expenses (in $) in Macao and Expenses (in $) in Netherlands?
Offer a terse response. -6.01e+09. In the year 2007, what is the difference between the Expenses (in $) in Macao and Expenses (in $) in Spain?
Provide a short and direct response. 1.32e+09. In the year 2007, what is the difference between the Expenses (in $) of Netherlands and Expenses (in $) of Spain?
Provide a short and direct response. 7.33e+09. What is the ratio of the Expenses (in $) of Lesotho in 1996 to that in 2001?
Offer a terse response. 1.36. What is the ratio of the Expenses (in $) in Macao in 1996 to that in 2001?
Provide a short and direct response. 0.82. What is the ratio of the Expenses (in $) of Netherlands in 1996 to that in 2001?
Offer a very short reply. 0.59. What is the ratio of the Expenses (in $) of Spain in 1996 to that in 2001?
Your answer should be very brief. 1.16. What is the ratio of the Expenses (in $) in Lesotho in 1996 to that in 2002?
Offer a terse response. 1.12. What is the ratio of the Expenses (in $) of Macao in 1996 to that in 2002?
Make the answer very short. 1.03. What is the ratio of the Expenses (in $) of Netherlands in 1996 to that in 2002?
Provide a short and direct response. 0.54. What is the ratio of the Expenses (in $) in Spain in 1996 to that in 2002?
Give a very brief answer. 6.94. What is the ratio of the Expenses (in $) in Lesotho in 1996 to that in 2003?
Provide a succinct answer. 0.69. What is the ratio of the Expenses (in $) in Macao in 1996 to that in 2003?
Keep it short and to the point. 0.97. What is the ratio of the Expenses (in $) in Netherlands in 1996 to that in 2003?
Provide a short and direct response. 0.61. What is the ratio of the Expenses (in $) of Spain in 1996 to that in 2003?
Provide a short and direct response. 4.53. What is the ratio of the Expenses (in $) in Lesotho in 1996 to that in 2004?
Make the answer very short. 0.4. What is the ratio of the Expenses (in $) of Macao in 1996 to that in 2004?
Offer a very short reply. 0.72. What is the ratio of the Expenses (in $) of Netherlands in 1996 to that in 2004?
Keep it short and to the point. 0.58. What is the ratio of the Expenses (in $) of Spain in 1996 to that in 2004?
Your response must be concise. 4.39. What is the ratio of the Expenses (in $) of Lesotho in 1996 to that in 2005?
Your answer should be compact. 1.07. What is the ratio of the Expenses (in $) of Macao in 1996 to that in 2005?
Provide a succinct answer. 0.62. What is the ratio of the Expenses (in $) of Netherlands in 1996 to that in 2005?
Offer a terse response. 0.5. What is the ratio of the Expenses (in $) in Spain in 1996 to that in 2005?
Offer a terse response. 3.33. What is the ratio of the Expenses (in $) in Lesotho in 1996 to that in 2006?
Ensure brevity in your answer.  0.1. What is the ratio of the Expenses (in $) of Macao in 1996 to that in 2006?
Provide a short and direct response. 0.64. What is the ratio of the Expenses (in $) in Netherlands in 1996 to that in 2006?
Give a very brief answer. 0.5. What is the ratio of the Expenses (in $) of Spain in 1996 to that in 2006?
Provide a short and direct response. 2.81. What is the ratio of the Expenses (in $) of Lesotho in 1996 to that in 2007?
Give a very brief answer. 1.09. What is the ratio of the Expenses (in $) in Macao in 1996 to that in 2007?
Offer a very short reply. 0.48. What is the ratio of the Expenses (in $) in Netherlands in 1996 to that in 2007?
Your answer should be compact. 0.46. What is the ratio of the Expenses (in $) of Spain in 1996 to that in 2007?
Your response must be concise. 2.25. What is the ratio of the Expenses (in $) in Lesotho in 2001 to that in 2002?
Provide a short and direct response. 0.83. What is the ratio of the Expenses (in $) of Macao in 2001 to that in 2002?
Make the answer very short. 1.25. What is the ratio of the Expenses (in $) in Netherlands in 2001 to that in 2002?
Offer a terse response. 0.93. What is the ratio of the Expenses (in $) of Spain in 2001 to that in 2002?
Your response must be concise. 5.98. What is the ratio of the Expenses (in $) of Lesotho in 2001 to that in 2003?
Provide a short and direct response. 0.51. What is the ratio of the Expenses (in $) of Macao in 2001 to that in 2003?
Make the answer very short. 1.18. What is the ratio of the Expenses (in $) of Netherlands in 2001 to that in 2003?
Your answer should be compact. 1.04. What is the ratio of the Expenses (in $) in Spain in 2001 to that in 2003?
Keep it short and to the point. 3.91. What is the ratio of the Expenses (in $) of Lesotho in 2001 to that in 2004?
Your response must be concise. 0.3. What is the ratio of the Expenses (in $) of Macao in 2001 to that in 2004?
Your response must be concise. 0.88. What is the ratio of the Expenses (in $) in Spain in 2001 to that in 2004?
Provide a succinct answer. 3.79. What is the ratio of the Expenses (in $) in Lesotho in 2001 to that in 2005?
Your answer should be very brief. 0.79. What is the ratio of the Expenses (in $) of Macao in 2001 to that in 2005?
Keep it short and to the point. 0.75. What is the ratio of the Expenses (in $) in Netherlands in 2001 to that in 2005?
Give a very brief answer. 0.86. What is the ratio of the Expenses (in $) in Spain in 2001 to that in 2005?
Your answer should be compact. 2.88. What is the ratio of the Expenses (in $) of Lesotho in 2001 to that in 2006?
Ensure brevity in your answer.  0.07. What is the ratio of the Expenses (in $) in Macao in 2001 to that in 2006?
Your answer should be very brief. 0.78. What is the ratio of the Expenses (in $) of Netherlands in 2001 to that in 2006?
Give a very brief answer. 0.85. What is the ratio of the Expenses (in $) in Spain in 2001 to that in 2006?
Ensure brevity in your answer.  2.42. What is the ratio of the Expenses (in $) of Lesotho in 2001 to that in 2007?
Make the answer very short. 0.8. What is the ratio of the Expenses (in $) in Macao in 2001 to that in 2007?
Provide a succinct answer. 0.59. What is the ratio of the Expenses (in $) of Netherlands in 2001 to that in 2007?
Offer a very short reply. 0.78. What is the ratio of the Expenses (in $) of Spain in 2001 to that in 2007?
Keep it short and to the point. 1.94. What is the ratio of the Expenses (in $) in Lesotho in 2002 to that in 2003?
Ensure brevity in your answer.  0.61. What is the ratio of the Expenses (in $) in Macao in 2002 to that in 2003?
Offer a terse response. 0.95. What is the ratio of the Expenses (in $) in Netherlands in 2002 to that in 2003?
Offer a terse response. 1.12. What is the ratio of the Expenses (in $) in Spain in 2002 to that in 2003?
Ensure brevity in your answer.  0.65. What is the ratio of the Expenses (in $) of Lesotho in 2002 to that in 2004?
Your answer should be compact. 0.36. What is the ratio of the Expenses (in $) in Macao in 2002 to that in 2004?
Ensure brevity in your answer.  0.7. What is the ratio of the Expenses (in $) in Netherlands in 2002 to that in 2004?
Give a very brief answer. 1.06. What is the ratio of the Expenses (in $) in Spain in 2002 to that in 2004?
Make the answer very short. 0.63. What is the ratio of the Expenses (in $) in Lesotho in 2002 to that in 2005?
Make the answer very short. 0.95. What is the ratio of the Expenses (in $) in Macao in 2002 to that in 2005?
Make the answer very short. 0.6. What is the ratio of the Expenses (in $) of Netherlands in 2002 to that in 2005?
Ensure brevity in your answer.  0.93. What is the ratio of the Expenses (in $) of Spain in 2002 to that in 2005?
Your answer should be compact. 0.48. What is the ratio of the Expenses (in $) in Lesotho in 2002 to that in 2006?
Keep it short and to the point. 0.09. What is the ratio of the Expenses (in $) of Macao in 2002 to that in 2006?
Your answer should be very brief. 0.62. What is the ratio of the Expenses (in $) of Netherlands in 2002 to that in 2006?
Offer a very short reply. 0.91. What is the ratio of the Expenses (in $) of Spain in 2002 to that in 2006?
Ensure brevity in your answer.  0.41. What is the ratio of the Expenses (in $) in Lesotho in 2002 to that in 2007?
Offer a terse response. 0.97. What is the ratio of the Expenses (in $) in Macao in 2002 to that in 2007?
Offer a terse response. 0.47. What is the ratio of the Expenses (in $) of Netherlands in 2002 to that in 2007?
Provide a short and direct response. 0.84. What is the ratio of the Expenses (in $) in Spain in 2002 to that in 2007?
Provide a short and direct response. 0.32. What is the ratio of the Expenses (in $) in Lesotho in 2003 to that in 2004?
Offer a terse response. 0.59. What is the ratio of the Expenses (in $) of Macao in 2003 to that in 2004?
Provide a short and direct response. 0.74. What is the ratio of the Expenses (in $) of Netherlands in 2003 to that in 2004?
Provide a succinct answer. 0.95. What is the ratio of the Expenses (in $) in Spain in 2003 to that in 2004?
Your answer should be compact. 0.97. What is the ratio of the Expenses (in $) of Lesotho in 2003 to that in 2005?
Make the answer very short. 1.56. What is the ratio of the Expenses (in $) of Macao in 2003 to that in 2005?
Offer a terse response. 0.63. What is the ratio of the Expenses (in $) in Netherlands in 2003 to that in 2005?
Keep it short and to the point. 0.83. What is the ratio of the Expenses (in $) in Spain in 2003 to that in 2005?
Your answer should be very brief. 0.74. What is the ratio of the Expenses (in $) of Lesotho in 2003 to that in 2006?
Provide a succinct answer. 0.14. What is the ratio of the Expenses (in $) of Macao in 2003 to that in 2006?
Your response must be concise. 0.66. What is the ratio of the Expenses (in $) in Netherlands in 2003 to that in 2006?
Your answer should be compact. 0.81. What is the ratio of the Expenses (in $) in Spain in 2003 to that in 2006?
Your answer should be very brief. 0.62. What is the ratio of the Expenses (in $) in Lesotho in 2003 to that in 2007?
Your response must be concise. 1.58. What is the ratio of the Expenses (in $) in Macao in 2003 to that in 2007?
Your response must be concise. 0.5. What is the ratio of the Expenses (in $) in Netherlands in 2003 to that in 2007?
Ensure brevity in your answer.  0.75. What is the ratio of the Expenses (in $) of Spain in 2003 to that in 2007?
Give a very brief answer. 0.5. What is the ratio of the Expenses (in $) of Lesotho in 2004 to that in 2005?
Your answer should be compact. 2.64. What is the ratio of the Expenses (in $) in Macao in 2004 to that in 2005?
Offer a terse response. 0.85. What is the ratio of the Expenses (in $) in Netherlands in 2004 to that in 2005?
Your response must be concise. 0.87. What is the ratio of the Expenses (in $) in Spain in 2004 to that in 2005?
Your answer should be very brief. 0.76. What is the ratio of the Expenses (in $) in Lesotho in 2004 to that in 2006?
Your response must be concise. 0.24. What is the ratio of the Expenses (in $) in Macao in 2004 to that in 2006?
Keep it short and to the point. 0.89. What is the ratio of the Expenses (in $) of Netherlands in 2004 to that in 2006?
Offer a terse response. 0.86. What is the ratio of the Expenses (in $) in Spain in 2004 to that in 2006?
Offer a terse response. 0.64. What is the ratio of the Expenses (in $) of Lesotho in 2004 to that in 2007?
Provide a short and direct response. 2.69. What is the ratio of the Expenses (in $) in Macao in 2004 to that in 2007?
Offer a terse response. 0.67. What is the ratio of the Expenses (in $) of Netherlands in 2004 to that in 2007?
Make the answer very short. 0.79. What is the ratio of the Expenses (in $) of Spain in 2004 to that in 2007?
Give a very brief answer. 0.51. What is the ratio of the Expenses (in $) of Lesotho in 2005 to that in 2006?
Offer a very short reply. 0.09. What is the ratio of the Expenses (in $) of Macao in 2005 to that in 2006?
Offer a terse response. 1.04. What is the ratio of the Expenses (in $) in Netherlands in 2005 to that in 2006?
Offer a very short reply. 0.98. What is the ratio of the Expenses (in $) in Spain in 2005 to that in 2006?
Your response must be concise. 0.84. What is the ratio of the Expenses (in $) in Lesotho in 2005 to that in 2007?
Your answer should be very brief. 1.02. What is the ratio of the Expenses (in $) in Macao in 2005 to that in 2007?
Your answer should be very brief. 0.78. What is the ratio of the Expenses (in $) in Netherlands in 2005 to that in 2007?
Give a very brief answer. 0.91. What is the ratio of the Expenses (in $) of Spain in 2005 to that in 2007?
Your response must be concise. 0.68. What is the ratio of the Expenses (in $) of Lesotho in 2006 to that in 2007?
Keep it short and to the point. 11.3. What is the ratio of the Expenses (in $) of Macao in 2006 to that in 2007?
Keep it short and to the point. 0.75. What is the ratio of the Expenses (in $) in Netherlands in 2006 to that in 2007?
Ensure brevity in your answer.  0.93. What is the ratio of the Expenses (in $) of Spain in 2006 to that in 2007?
Ensure brevity in your answer.  0.8. What is the difference between the highest and the second highest Expenses (in $) of Lesotho?
Your response must be concise. 5.70e+07. What is the difference between the highest and the second highest Expenses (in $) of Macao?
Ensure brevity in your answer.  3.28e+08. What is the difference between the highest and the second highest Expenses (in $) of Netherlands?
Provide a succinct answer. 5.64e+08. What is the difference between the highest and the second highest Expenses (in $) in Spain?
Your answer should be compact. 5.90e+07. What is the difference between the highest and the lowest Expenses (in $) of Lesotho?
Make the answer very short. 6.95e+07. What is the difference between the highest and the lowest Expenses (in $) of Macao?
Ensure brevity in your answer.  8.01e+08. What is the difference between the highest and the lowest Expenses (in $) of Netherlands?
Offer a very short reply. 4.07e+09. What is the difference between the highest and the lowest Expenses (in $) in Spain?
Provide a short and direct response. 3.68e+08. 